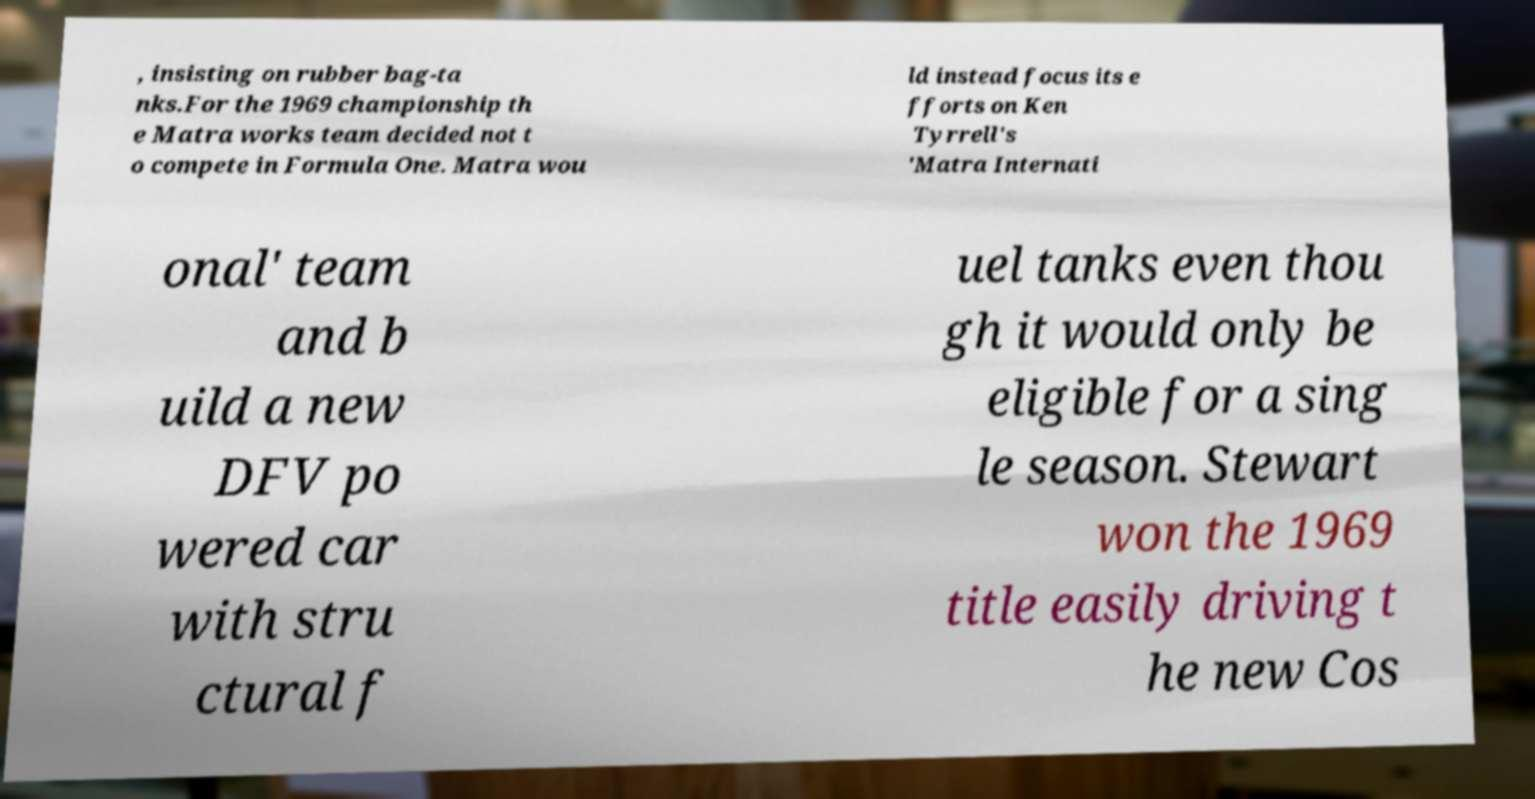I need the written content from this picture converted into text. Can you do that? , insisting on rubber bag-ta nks.For the 1969 championship th e Matra works team decided not t o compete in Formula One. Matra wou ld instead focus its e fforts on Ken Tyrrell's 'Matra Internati onal' team and b uild a new DFV po wered car with stru ctural f uel tanks even thou gh it would only be eligible for a sing le season. Stewart won the 1969 title easily driving t he new Cos 